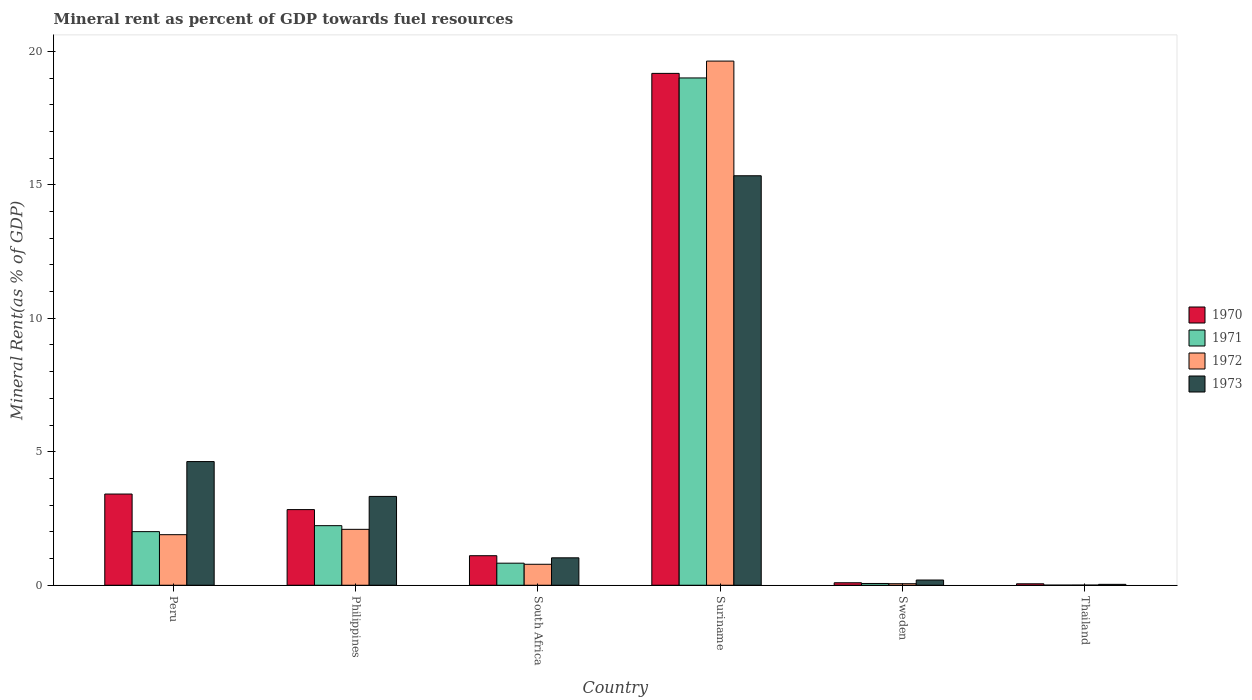How many different coloured bars are there?
Offer a terse response. 4. How many bars are there on the 5th tick from the right?
Provide a succinct answer. 4. In how many cases, is the number of bars for a given country not equal to the number of legend labels?
Ensure brevity in your answer.  0. What is the mineral rent in 1971 in Peru?
Provide a short and direct response. 2.01. Across all countries, what is the maximum mineral rent in 1970?
Offer a terse response. 19.17. Across all countries, what is the minimum mineral rent in 1970?
Make the answer very short. 0.05. In which country was the mineral rent in 1973 maximum?
Provide a short and direct response. Suriname. In which country was the mineral rent in 1972 minimum?
Ensure brevity in your answer.  Thailand. What is the total mineral rent in 1973 in the graph?
Provide a short and direct response. 24.55. What is the difference between the mineral rent in 1972 in Peru and that in South Africa?
Your answer should be very brief. 1.11. What is the difference between the mineral rent in 1971 in Sweden and the mineral rent in 1970 in Peru?
Keep it short and to the point. -3.35. What is the average mineral rent in 1973 per country?
Give a very brief answer. 4.09. What is the difference between the mineral rent of/in 1972 and mineral rent of/in 1971 in Peru?
Make the answer very short. -0.11. What is the ratio of the mineral rent in 1973 in Philippines to that in Suriname?
Give a very brief answer. 0.22. Is the mineral rent in 1973 in Peru less than that in Suriname?
Your answer should be very brief. Yes. Is the difference between the mineral rent in 1972 in South Africa and Sweden greater than the difference between the mineral rent in 1971 in South Africa and Sweden?
Make the answer very short. No. What is the difference between the highest and the second highest mineral rent in 1972?
Give a very brief answer. -0.2. What is the difference between the highest and the lowest mineral rent in 1972?
Your answer should be compact. 19.63. Is it the case that in every country, the sum of the mineral rent in 1971 and mineral rent in 1973 is greater than the sum of mineral rent in 1970 and mineral rent in 1972?
Keep it short and to the point. No. How many bars are there?
Provide a succinct answer. 24. Are all the bars in the graph horizontal?
Your answer should be compact. No. Does the graph contain any zero values?
Your answer should be compact. No. Where does the legend appear in the graph?
Your answer should be very brief. Center right. How many legend labels are there?
Offer a terse response. 4. What is the title of the graph?
Offer a very short reply. Mineral rent as percent of GDP towards fuel resources. Does "1980" appear as one of the legend labels in the graph?
Give a very brief answer. No. What is the label or title of the Y-axis?
Make the answer very short. Mineral Rent(as % of GDP). What is the Mineral Rent(as % of GDP) in 1970 in Peru?
Give a very brief answer. 3.42. What is the Mineral Rent(as % of GDP) in 1971 in Peru?
Provide a succinct answer. 2.01. What is the Mineral Rent(as % of GDP) in 1972 in Peru?
Your answer should be compact. 1.89. What is the Mineral Rent(as % of GDP) in 1973 in Peru?
Keep it short and to the point. 4.63. What is the Mineral Rent(as % of GDP) of 1970 in Philippines?
Ensure brevity in your answer.  2.83. What is the Mineral Rent(as % of GDP) in 1971 in Philippines?
Keep it short and to the point. 2.23. What is the Mineral Rent(as % of GDP) in 1972 in Philippines?
Ensure brevity in your answer.  2.09. What is the Mineral Rent(as % of GDP) in 1973 in Philippines?
Provide a succinct answer. 3.33. What is the Mineral Rent(as % of GDP) in 1970 in South Africa?
Ensure brevity in your answer.  1.11. What is the Mineral Rent(as % of GDP) in 1971 in South Africa?
Offer a terse response. 0.83. What is the Mineral Rent(as % of GDP) of 1972 in South Africa?
Your answer should be very brief. 0.79. What is the Mineral Rent(as % of GDP) in 1973 in South Africa?
Offer a very short reply. 1.03. What is the Mineral Rent(as % of GDP) of 1970 in Suriname?
Keep it short and to the point. 19.17. What is the Mineral Rent(as % of GDP) of 1971 in Suriname?
Your answer should be very brief. 19. What is the Mineral Rent(as % of GDP) in 1972 in Suriname?
Your response must be concise. 19.63. What is the Mineral Rent(as % of GDP) of 1973 in Suriname?
Your answer should be very brief. 15.34. What is the Mineral Rent(as % of GDP) of 1970 in Sweden?
Provide a short and direct response. 0.09. What is the Mineral Rent(as % of GDP) in 1971 in Sweden?
Offer a very short reply. 0.07. What is the Mineral Rent(as % of GDP) of 1972 in Sweden?
Provide a short and direct response. 0.06. What is the Mineral Rent(as % of GDP) in 1973 in Sweden?
Provide a short and direct response. 0.2. What is the Mineral Rent(as % of GDP) in 1970 in Thailand?
Provide a short and direct response. 0.05. What is the Mineral Rent(as % of GDP) in 1971 in Thailand?
Your response must be concise. 0. What is the Mineral Rent(as % of GDP) in 1972 in Thailand?
Give a very brief answer. 0.01. What is the Mineral Rent(as % of GDP) in 1973 in Thailand?
Offer a very short reply. 0.03. Across all countries, what is the maximum Mineral Rent(as % of GDP) in 1970?
Your answer should be very brief. 19.17. Across all countries, what is the maximum Mineral Rent(as % of GDP) in 1971?
Offer a very short reply. 19. Across all countries, what is the maximum Mineral Rent(as % of GDP) in 1972?
Your answer should be compact. 19.63. Across all countries, what is the maximum Mineral Rent(as % of GDP) of 1973?
Your answer should be very brief. 15.34. Across all countries, what is the minimum Mineral Rent(as % of GDP) of 1970?
Give a very brief answer. 0.05. Across all countries, what is the minimum Mineral Rent(as % of GDP) of 1971?
Offer a very short reply. 0. Across all countries, what is the minimum Mineral Rent(as % of GDP) in 1972?
Make the answer very short. 0.01. Across all countries, what is the minimum Mineral Rent(as % of GDP) of 1973?
Give a very brief answer. 0.03. What is the total Mineral Rent(as % of GDP) of 1970 in the graph?
Ensure brevity in your answer.  26.68. What is the total Mineral Rent(as % of GDP) in 1971 in the graph?
Your answer should be compact. 24.14. What is the total Mineral Rent(as % of GDP) in 1972 in the graph?
Your response must be concise. 24.47. What is the total Mineral Rent(as % of GDP) in 1973 in the graph?
Keep it short and to the point. 24.55. What is the difference between the Mineral Rent(as % of GDP) in 1970 in Peru and that in Philippines?
Offer a terse response. 0.58. What is the difference between the Mineral Rent(as % of GDP) of 1971 in Peru and that in Philippines?
Ensure brevity in your answer.  -0.22. What is the difference between the Mineral Rent(as % of GDP) in 1972 in Peru and that in Philippines?
Your answer should be compact. -0.2. What is the difference between the Mineral Rent(as % of GDP) in 1973 in Peru and that in Philippines?
Provide a succinct answer. 1.31. What is the difference between the Mineral Rent(as % of GDP) of 1970 in Peru and that in South Africa?
Your answer should be very brief. 2.31. What is the difference between the Mineral Rent(as % of GDP) in 1971 in Peru and that in South Africa?
Your answer should be very brief. 1.18. What is the difference between the Mineral Rent(as % of GDP) in 1972 in Peru and that in South Africa?
Ensure brevity in your answer.  1.11. What is the difference between the Mineral Rent(as % of GDP) in 1973 in Peru and that in South Africa?
Ensure brevity in your answer.  3.61. What is the difference between the Mineral Rent(as % of GDP) in 1970 in Peru and that in Suriname?
Provide a succinct answer. -15.76. What is the difference between the Mineral Rent(as % of GDP) in 1971 in Peru and that in Suriname?
Your answer should be very brief. -16.99. What is the difference between the Mineral Rent(as % of GDP) in 1972 in Peru and that in Suriname?
Offer a terse response. -17.74. What is the difference between the Mineral Rent(as % of GDP) in 1973 in Peru and that in Suriname?
Offer a very short reply. -10.71. What is the difference between the Mineral Rent(as % of GDP) in 1970 in Peru and that in Sweden?
Your answer should be compact. 3.32. What is the difference between the Mineral Rent(as % of GDP) in 1971 in Peru and that in Sweden?
Ensure brevity in your answer.  1.94. What is the difference between the Mineral Rent(as % of GDP) of 1972 in Peru and that in Sweden?
Provide a succinct answer. 1.84. What is the difference between the Mineral Rent(as % of GDP) of 1973 in Peru and that in Sweden?
Keep it short and to the point. 4.44. What is the difference between the Mineral Rent(as % of GDP) of 1970 in Peru and that in Thailand?
Make the answer very short. 3.36. What is the difference between the Mineral Rent(as % of GDP) of 1971 in Peru and that in Thailand?
Your answer should be very brief. 2. What is the difference between the Mineral Rent(as % of GDP) of 1972 in Peru and that in Thailand?
Your answer should be compact. 1.89. What is the difference between the Mineral Rent(as % of GDP) of 1973 in Peru and that in Thailand?
Provide a short and direct response. 4.6. What is the difference between the Mineral Rent(as % of GDP) of 1970 in Philippines and that in South Africa?
Ensure brevity in your answer.  1.73. What is the difference between the Mineral Rent(as % of GDP) of 1971 in Philippines and that in South Africa?
Provide a succinct answer. 1.41. What is the difference between the Mineral Rent(as % of GDP) of 1972 in Philippines and that in South Africa?
Provide a succinct answer. 1.31. What is the difference between the Mineral Rent(as % of GDP) in 1973 in Philippines and that in South Africa?
Your response must be concise. 2.3. What is the difference between the Mineral Rent(as % of GDP) of 1970 in Philippines and that in Suriname?
Offer a terse response. -16.34. What is the difference between the Mineral Rent(as % of GDP) in 1971 in Philippines and that in Suriname?
Provide a short and direct response. -16.77. What is the difference between the Mineral Rent(as % of GDP) of 1972 in Philippines and that in Suriname?
Provide a short and direct response. -17.54. What is the difference between the Mineral Rent(as % of GDP) in 1973 in Philippines and that in Suriname?
Provide a succinct answer. -12.01. What is the difference between the Mineral Rent(as % of GDP) of 1970 in Philippines and that in Sweden?
Make the answer very short. 2.74. What is the difference between the Mineral Rent(as % of GDP) in 1971 in Philippines and that in Sweden?
Your answer should be very brief. 2.17. What is the difference between the Mineral Rent(as % of GDP) in 1972 in Philippines and that in Sweden?
Your response must be concise. 2.04. What is the difference between the Mineral Rent(as % of GDP) of 1973 in Philippines and that in Sweden?
Give a very brief answer. 3.13. What is the difference between the Mineral Rent(as % of GDP) in 1970 in Philippines and that in Thailand?
Your answer should be very brief. 2.78. What is the difference between the Mineral Rent(as % of GDP) in 1971 in Philippines and that in Thailand?
Your response must be concise. 2.23. What is the difference between the Mineral Rent(as % of GDP) of 1972 in Philippines and that in Thailand?
Provide a succinct answer. 2.09. What is the difference between the Mineral Rent(as % of GDP) in 1973 in Philippines and that in Thailand?
Offer a terse response. 3.29. What is the difference between the Mineral Rent(as % of GDP) in 1970 in South Africa and that in Suriname?
Offer a terse response. -18.07. What is the difference between the Mineral Rent(as % of GDP) of 1971 in South Africa and that in Suriname?
Your answer should be compact. -18.18. What is the difference between the Mineral Rent(as % of GDP) in 1972 in South Africa and that in Suriname?
Keep it short and to the point. -18.85. What is the difference between the Mineral Rent(as % of GDP) in 1973 in South Africa and that in Suriname?
Make the answer very short. -14.31. What is the difference between the Mineral Rent(as % of GDP) of 1970 in South Africa and that in Sweden?
Ensure brevity in your answer.  1.01. What is the difference between the Mineral Rent(as % of GDP) of 1971 in South Africa and that in Sweden?
Provide a succinct answer. 0.76. What is the difference between the Mineral Rent(as % of GDP) of 1972 in South Africa and that in Sweden?
Make the answer very short. 0.73. What is the difference between the Mineral Rent(as % of GDP) of 1973 in South Africa and that in Sweden?
Provide a succinct answer. 0.83. What is the difference between the Mineral Rent(as % of GDP) in 1970 in South Africa and that in Thailand?
Offer a terse response. 1.05. What is the difference between the Mineral Rent(as % of GDP) in 1971 in South Africa and that in Thailand?
Offer a terse response. 0.82. What is the difference between the Mineral Rent(as % of GDP) in 1972 in South Africa and that in Thailand?
Offer a very short reply. 0.78. What is the difference between the Mineral Rent(as % of GDP) in 1973 in South Africa and that in Thailand?
Ensure brevity in your answer.  0.99. What is the difference between the Mineral Rent(as % of GDP) of 1970 in Suriname and that in Sweden?
Keep it short and to the point. 19.08. What is the difference between the Mineral Rent(as % of GDP) in 1971 in Suriname and that in Sweden?
Offer a very short reply. 18.94. What is the difference between the Mineral Rent(as % of GDP) of 1972 in Suriname and that in Sweden?
Keep it short and to the point. 19.58. What is the difference between the Mineral Rent(as % of GDP) of 1973 in Suriname and that in Sweden?
Your response must be concise. 15.14. What is the difference between the Mineral Rent(as % of GDP) in 1970 in Suriname and that in Thailand?
Offer a very short reply. 19.12. What is the difference between the Mineral Rent(as % of GDP) in 1971 in Suriname and that in Thailand?
Your answer should be compact. 19. What is the difference between the Mineral Rent(as % of GDP) in 1972 in Suriname and that in Thailand?
Ensure brevity in your answer.  19.63. What is the difference between the Mineral Rent(as % of GDP) of 1973 in Suriname and that in Thailand?
Your response must be concise. 15.31. What is the difference between the Mineral Rent(as % of GDP) of 1970 in Sweden and that in Thailand?
Offer a terse response. 0.04. What is the difference between the Mineral Rent(as % of GDP) of 1971 in Sweden and that in Thailand?
Your response must be concise. 0.06. What is the difference between the Mineral Rent(as % of GDP) of 1972 in Sweden and that in Thailand?
Offer a very short reply. 0.05. What is the difference between the Mineral Rent(as % of GDP) in 1973 in Sweden and that in Thailand?
Provide a succinct answer. 0.16. What is the difference between the Mineral Rent(as % of GDP) of 1970 in Peru and the Mineral Rent(as % of GDP) of 1971 in Philippines?
Give a very brief answer. 1.18. What is the difference between the Mineral Rent(as % of GDP) in 1970 in Peru and the Mineral Rent(as % of GDP) in 1972 in Philippines?
Offer a very short reply. 1.32. What is the difference between the Mineral Rent(as % of GDP) of 1970 in Peru and the Mineral Rent(as % of GDP) of 1973 in Philippines?
Give a very brief answer. 0.09. What is the difference between the Mineral Rent(as % of GDP) of 1971 in Peru and the Mineral Rent(as % of GDP) of 1972 in Philippines?
Ensure brevity in your answer.  -0.09. What is the difference between the Mineral Rent(as % of GDP) in 1971 in Peru and the Mineral Rent(as % of GDP) in 1973 in Philippines?
Your answer should be compact. -1.32. What is the difference between the Mineral Rent(as % of GDP) in 1972 in Peru and the Mineral Rent(as % of GDP) in 1973 in Philippines?
Your response must be concise. -1.43. What is the difference between the Mineral Rent(as % of GDP) of 1970 in Peru and the Mineral Rent(as % of GDP) of 1971 in South Africa?
Your response must be concise. 2.59. What is the difference between the Mineral Rent(as % of GDP) of 1970 in Peru and the Mineral Rent(as % of GDP) of 1972 in South Africa?
Make the answer very short. 2.63. What is the difference between the Mineral Rent(as % of GDP) in 1970 in Peru and the Mineral Rent(as % of GDP) in 1973 in South Africa?
Provide a succinct answer. 2.39. What is the difference between the Mineral Rent(as % of GDP) of 1971 in Peru and the Mineral Rent(as % of GDP) of 1972 in South Africa?
Offer a terse response. 1.22. What is the difference between the Mineral Rent(as % of GDP) in 1971 in Peru and the Mineral Rent(as % of GDP) in 1973 in South Africa?
Your answer should be compact. 0.98. What is the difference between the Mineral Rent(as % of GDP) in 1972 in Peru and the Mineral Rent(as % of GDP) in 1973 in South Africa?
Ensure brevity in your answer.  0.87. What is the difference between the Mineral Rent(as % of GDP) of 1970 in Peru and the Mineral Rent(as % of GDP) of 1971 in Suriname?
Give a very brief answer. -15.59. What is the difference between the Mineral Rent(as % of GDP) in 1970 in Peru and the Mineral Rent(as % of GDP) in 1972 in Suriname?
Keep it short and to the point. -16.22. What is the difference between the Mineral Rent(as % of GDP) of 1970 in Peru and the Mineral Rent(as % of GDP) of 1973 in Suriname?
Give a very brief answer. -11.92. What is the difference between the Mineral Rent(as % of GDP) of 1971 in Peru and the Mineral Rent(as % of GDP) of 1972 in Suriname?
Your answer should be compact. -17.63. What is the difference between the Mineral Rent(as % of GDP) in 1971 in Peru and the Mineral Rent(as % of GDP) in 1973 in Suriname?
Make the answer very short. -13.33. What is the difference between the Mineral Rent(as % of GDP) of 1972 in Peru and the Mineral Rent(as % of GDP) of 1973 in Suriname?
Keep it short and to the point. -13.44. What is the difference between the Mineral Rent(as % of GDP) in 1970 in Peru and the Mineral Rent(as % of GDP) in 1971 in Sweden?
Your answer should be compact. 3.35. What is the difference between the Mineral Rent(as % of GDP) of 1970 in Peru and the Mineral Rent(as % of GDP) of 1972 in Sweden?
Offer a very short reply. 3.36. What is the difference between the Mineral Rent(as % of GDP) of 1970 in Peru and the Mineral Rent(as % of GDP) of 1973 in Sweden?
Make the answer very short. 3.22. What is the difference between the Mineral Rent(as % of GDP) in 1971 in Peru and the Mineral Rent(as % of GDP) in 1972 in Sweden?
Provide a succinct answer. 1.95. What is the difference between the Mineral Rent(as % of GDP) in 1971 in Peru and the Mineral Rent(as % of GDP) in 1973 in Sweden?
Keep it short and to the point. 1.81. What is the difference between the Mineral Rent(as % of GDP) of 1972 in Peru and the Mineral Rent(as % of GDP) of 1973 in Sweden?
Your answer should be very brief. 1.7. What is the difference between the Mineral Rent(as % of GDP) in 1970 in Peru and the Mineral Rent(as % of GDP) in 1971 in Thailand?
Give a very brief answer. 3.41. What is the difference between the Mineral Rent(as % of GDP) in 1970 in Peru and the Mineral Rent(as % of GDP) in 1972 in Thailand?
Provide a succinct answer. 3.41. What is the difference between the Mineral Rent(as % of GDP) of 1970 in Peru and the Mineral Rent(as % of GDP) of 1973 in Thailand?
Your response must be concise. 3.38. What is the difference between the Mineral Rent(as % of GDP) of 1971 in Peru and the Mineral Rent(as % of GDP) of 1972 in Thailand?
Give a very brief answer. 2. What is the difference between the Mineral Rent(as % of GDP) of 1971 in Peru and the Mineral Rent(as % of GDP) of 1973 in Thailand?
Your answer should be compact. 1.97. What is the difference between the Mineral Rent(as % of GDP) of 1972 in Peru and the Mineral Rent(as % of GDP) of 1973 in Thailand?
Make the answer very short. 1.86. What is the difference between the Mineral Rent(as % of GDP) in 1970 in Philippines and the Mineral Rent(as % of GDP) in 1971 in South Africa?
Give a very brief answer. 2.01. What is the difference between the Mineral Rent(as % of GDP) in 1970 in Philippines and the Mineral Rent(as % of GDP) in 1972 in South Africa?
Your answer should be compact. 2.05. What is the difference between the Mineral Rent(as % of GDP) of 1970 in Philippines and the Mineral Rent(as % of GDP) of 1973 in South Africa?
Your response must be concise. 1.81. What is the difference between the Mineral Rent(as % of GDP) of 1971 in Philippines and the Mineral Rent(as % of GDP) of 1972 in South Africa?
Make the answer very short. 1.45. What is the difference between the Mineral Rent(as % of GDP) in 1971 in Philippines and the Mineral Rent(as % of GDP) in 1973 in South Africa?
Your answer should be very brief. 1.2. What is the difference between the Mineral Rent(as % of GDP) in 1972 in Philippines and the Mineral Rent(as % of GDP) in 1973 in South Africa?
Provide a succinct answer. 1.07. What is the difference between the Mineral Rent(as % of GDP) of 1970 in Philippines and the Mineral Rent(as % of GDP) of 1971 in Suriname?
Your answer should be compact. -16.17. What is the difference between the Mineral Rent(as % of GDP) of 1970 in Philippines and the Mineral Rent(as % of GDP) of 1972 in Suriname?
Make the answer very short. -16.8. What is the difference between the Mineral Rent(as % of GDP) in 1970 in Philippines and the Mineral Rent(as % of GDP) in 1973 in Suriname?
Offer a terse response. -12.51. What is the difference between the Mineral Rent(as % of GDP) in 1971 in Philippines and the Mineral Rent(as % of GDP) in 1972 in Suriname?
Your answer should be compact. -17.4. What is the difference between the Mineral Rent(as % of GDP) in 1971 in Philippines and the Mineral Rent(as % of GDP) in 1973 in Suriname?
Your response must be concise. -13.11. What is the difference between the Mineral Rent(as % of GDP) of 1972 in Philippines and the Mineral Rent(as % of GDP) of 1973 in Suriname?
Your response must be concise. -13.24. What is the difference between the Mineral Rent(as % of GDP) in 1970 in Philippines and the Mineral Rent(as % of GDP) in 1971 in Sweden?
Offer a terse response. 2.77. What is the difference between the Mineral Rent(as % of GDP) in 1970 in Philippines and the Mineral Rent(as % of GDP) in 1972 in Sweden?
Give a very brief answer. 2.78. What is the difference between the Mineral Rent(as % of GDP) of 1970 in Philippines and the Mineral Rent(as % of GDP) of 1973 in Sweden?
Make the answer very short. 2.64. What is the difference between the Mineral Rent(as % of GDP) of 1971 in Philippines and the Mineral Rent(as % of GDP) of 1972 in Sweden?
Provide a short and direct response. 2.17. What is the difference between the Mineral Rent(as % of GDP) of 1971 in Philippines and the Mineral Rent(as % of GDP) of 1973 in Sweden?
Your response must be concise. 2.04. What is the difference between the Mineral Rent(as % of GDP) in 1972 in Philippines and the Mineral Rent(as % of GDP) in 1973 in Sweden?
Offer a terse response. 1.9. What is the difference between the Mineral Rent(as % of GDP) of 1970 in Philippines and the Mineral Rent(as % of GDP) of 1971 in Thailand?
Your answer should be compact. 2.83. What is the difference between the Mineral Rent(as % of GDP) in 1970 in Philippines and the Mineral Rent(as % of GDP) in 1972 in Thailand?
Your response must be concise. 2.83. What is the difference between the Mineral Rent(as % of GDP) in 1970 in Philippines and the Mineral Rent(as % of GDP) in 1973 in Thailand?
Offer a very short reply. 2.8. What is the difference between the Mineral Rent(as % of GDP) of 1971 in Philippines and the Mineral Rent(as % of GDP) of 1972 in Thailand?
Give a very brief answer. 2.23. What is the difference between the Mineral Rent(as % of GDP) of 1971 in Philippines and the Mineral Rent(as % of GDP) of 1973 in Thailand?
Give a very brief answer. 2.2. What is the difference between the Mineral Rent(as % of GDP) of 1972 in Philippines and the Mineral Rent(as % of GDP) of 1973 in Thailand?
Provide a short and direct response. 2.06. What is the difference between the Mineral Rent(as % of GDP) in 1970 in South Africa and the Mineral Rent(as % of GDP) in 1971 in Suriname?
Ensure brevity in your answer.  -17.9. What is the difference between the Mineral Rent(as % of GDP) in 1970 in South Africa and the Mineral Rent(as % of GDP) in 1972 in Suriname?
Offer a very short reply. -18.53. What is the difference between the Mineral Rent(as % of GDP) of 1970 in South Africa and the Mineral Rent(as % of GDP) of 1973 in Suriname?
Your answer should be very brief. -14.23. What is the difference between the Mineral Rent(as % of GDP) in 1971 in South Africa and the Mineral Rent(as % of GDP) in 1972 in Suriname?
Offer a terse response. -18.81. What is the difference between the Mineral Rent(as % of GDP) in 1971 in South Africa and the Mineral Rent(as % of GDP) in 1973 in Suriname?
Give a very brief answer. -14.51. What is the difference between the Mineral Rent(as % of GDP) of 1972 in South Africa and the Mineral Rent(as % of GDP) of 1973 in Suriname?
Offer a terse response. -14.55. What is the difference between the Mineral Rent(as % of GDP) in 1970 in South Africa and the Mineral Rent(as % of GDP) in 1971 in Sweden?
Offer a very short reply. 1.04. What is the difference between the Mineral Rent(as % of GDP) of 1970 in South Africa and the Mineral Rent(as % of GDP) of 1972 in Sweden?
Your response must be concise. 1.05. What is the difference between the Mineral Rent(as % of GDP) of 1970 in South Africa and the Mineral Rent(as % of GDP) of 1973 in Sweden?
Offer a terse response. 0.91. What is the difference between the Mineral Rent(as % of GDP) of 1971 in South Africa and the Mineral Rent(as % of GDP) of 1972 in Sweden?
Your answer should be very brief. 0.77. What is the difference between the Mineral Rent(as % of GDP) of 1971 in South Africa and the Mineral Rent(as % of GDP) of 1973 in Sweden?
Provide a short and direct response. 0.63. What is the difference between the Mineral Rent(as % of GDP) in 1972 in South Africa and the Mineral Rent(as % of GDP) in 1973 in Sweden?
Make the answer very short. 0.59. What is the difference between the Mineral Rent(as % of GDP) in 1970 in South Africa and the Mineral Rent(as % of GDP) in 1971 in Thailand?
Make the answer very short. 1.1. What is the difference between the Mineral Rent(as % of GDP) in 1970 in South Africa and the Mineral Rent(as % of GDP) in 1972 in Thailand?
Give a very brief answer. 1.1. What is the difference between the Mineral Rent(as % of GDP) of 1970 in South Africa and the Mineral Rent(as % of GDP) of 1973 in Thailand?
Your answer should be compact. 1.07. What is the difference between the Mineral Rent(as % of GDP) in 1971 in South Africa and the Mineral Rent(as % of GDP) in 1972 in Thailand?
Provide a short and direct response. 0.82. What is the difference between the Mineral Rent(as % of GDP) of 1971 in South Africa and the Mineral Rent(as % of GDP) of 1973 in Thailand?
Keep it short and to the point. 0.79. What is the difference between the Mineral Rent(as % of GDP) of 1972 in South Africa and the Mineral Rent(as % of GDP) of 1973 in Thailand?
Give a very brief answer. 0.75. What is the difference between the Mineral Rent(as % of GDP) in 1970 in Suriname and the Mineral Rent(as % of GDP) in 1971 in Sweden?
Your answer should be very brief. 19.11. What is the difference between the Mineral Rent(as % of GDP) of 1970 in Suriname and the Mineral Rent(as % of GDP) of 1972 in Sweden?
Give a very brief answer. 19.12. What is the difference between the Mineral Rent(as % of GDP) of 1970 in Suriname and the Mineral Rent(as % of GDP) of 1973 in Sweden?
Your response must be concise. 18.98. What is the difference between the Mineral Rent(as % of GDP) of 1971 in Suriname and the Mineral Rent(as % of GDP) of 1972 in Sweden?
Your answer should be very brief. 18.95. What is the difference between the Mineral Rent(as % of GDP) in 1971 in Suriname and the Mineral Rent(as % of GDP) in 1973 in Sweden?
Offer a terse response. 18.81. What is the difference between the Mineral Rent(as % of GDP) of 1972 in Suriname and the Mineral Rent(as % of GDP) of 1973 in Sweden?
Keep it short and to the point. 19.44. What is the difference between the Mineral Rent(as % of GDP) in 1970 in Suriname and the Mineral Rent(as % of GDP) in 1971 in Thailand?
Provide a succinct answer. 19.17. What is the difference between the Mineral Rent(as % of GDP) in 1970 in Suriname and the Mineral Rent(as % of GDP) in 1972 in Thailand?
Provide a succinct answer. 19.17. What is the difference between the Mineral Rent(as % of GDP) of 1970 in Suriname and the Mineral Rent(as % of GDP) of 1973 in Thailand?
Your response must be concise. 19.14. What is the difference between the Mineral Rent(as % of GDP) of 1971 in Suriname and the Mineral Rent(as % of GDP) of 1972 in Thailand?
Offer a terse response. 19. What is the difference between the Mineral Rent(as % of GDP) of 1971 in Suriname and the Mineral Rent(as % of GDP) of 1973 in Thailand?
Ensure brevity in your answer.  18.97. What is the difference between the Mineral Rent(as % of GDP) of 1972 in Suriname and the Mineral Rent(as % of GDP) of 1973 in Thailand?
Ensure brevity in your answer.  19.6. What is the difference between the Mineral Rent(as % of GDP) of 1970 in Sweden and the Mineral Rent(as % of GDP) of 1971 in Thailand?
Offer a terse response. 0.09. What is the difference between the Mineral Rent(as % of GDP) in 1970 in Sweden and the Mineral Rent(as % of GDP) in 1972 in Thailand?
Give a very brief answer. 0.09. What is the difference between the Mineral Rent(as % of GDP) in 1970 in Sweden and the Mineral Rent(as % of GDP) in 1973 in Thailand?
Make the answer very short. 0.06. What is the difference between the Mineral Rent(as % of GDP) of 1971 in Sweden and the Mineral Rent(as % of GDP) of 1972 in Thailand?
Your response must be concise. 0.06. What is the difference between the Mineral Rent(as % of GDP) in 1971 in Sweden and the Mineral Rent(as % of GDP) in 1973 in Thailand?
Your answer should be compact. 0.03. What is the difference between the Mineral Rent(as % of GDP) of 1972 in Sweden and the Mineral Rent(as % of GDP) of 1973 in Thailand?
Your response must be concise. 0.02. What is the average Mineral Rent(as % of GDP) in 1970 per country?
Your response must be concise. 4.45. What is the average Mineral Rent(as % of GDP) of 1971 per country?
Your response must be concise. 4.02. What is the average Mineral Rent(as % of GDP) of 1972 per country?
Offer a very short reply. 4.08. What is the average Mineral Rent(as % of GDP) in 1973 per country?
Your answer should be compact. 4.09. What is the difference between the Mineral Rent(as % of GDP) of 1970 and Mineral Rent(as % of GDP) of 1971 in Peru?
Offer a terse response. 1.41. What is the difference between the Mineral Rent(as % of GDP) of 1970 and Mineral Rent(as % of GDP) of 1972 in Peru?
Offer a terse response. 1.52. What is the difference between the Mineral Rent(as % of GDP) in 1970 and Mineral Rent(as % of GDP) in 1973 in Peru?
Provide a short and direct response. -1.22. What is the difference between the Mineral Rent(as % of GDP) of 1971 and Mineral Rent(as % of GDP) of 1972 in Peru?
Keep it short and to the point. 0.11. What is the difference between the Mineral Rent(as % of GDP) of 1971 and Mineral Rent(as % of GDP) of 1973 in Peru?
Give a very brief answer. -2.62. What is the difference between the Mineral Rent(as % of GDP) in 1972 and Mineral Rent(as % of GDP) in 1973 in Peru?
Offer a terse response. -2.74. What is the difference between the Mineral Rent(as % of GDP) of 1970 and Mineral Rent(as % of GDP) of 1971 in Philippines?
Offer a very short reply. 0.6. What is the difference between the Mineral Rent(as % of GDP) in 1970 and Mineral Rent(as % of GDP) in 1972 in Philippines?
Your answer should be compact. 0.74. What is the difference between the Mineral Rent(as % of GDP) in 1970 and Mineral Rent(as % of GDP) in 1973 in Philippines?
Offer a very short reply. -0.49. What is the difference between the Mineral Rent(as % of GDP) in 1971 and Mineral Rent(as % of GDP) in 1972 in Philippines?
Provide a short and direct response. 0.14. What is the difference between the Mineral Rent(as % of GDP) of 1971 and Mineral Rent(as % of GDP) of 1973 in Philippines?
Your answer should be compact. -1.1. What is the difference between the Mineral Rent(as % of GDP) of 1972 and Mineral Rent(as % of GDP) of 1973 in Philippines?
Ensure brevity in your answer.  -1.23. What is the difference between the Mineral Rent(as % of GDP) of 1970 and Mineral Rent(as % of GDP) of 1971 in South Africa?
Your answer should be compact. 0.28. What is the difference between the Mineral Rent(as % of GDP) in 1970 and Mineral Rent(as % of GDP) in 1972 in South Africa?
Your answer should be compact. 0.32. What is the difference between the Mineral Rent(as % of GDP) of 1970 and Mineral Rent(as % of GDP) of 1973 in South Africa?
Offer a very short reply. 0.08. What is the difference between the Mineral Rent(as % of GDP) of 1971 and Mineral Rent(as % of GDP) of 1972 in South Africa?
Your answer should be compact. 0.04. What is the difference between the Mineral Rent(as % of GDP) in 1971 and Mineral Rent(as % of GDP) in 1973 in South Africa?
Your answer should be compact. -0.2. What is the difference between the Mineral Rent(as % of GDP) of 1972 and Mineral Rent(as % of GDP) of 1973 in South Africa?
Offer a terse response. -0.24. What is the difference between the Mineral Rent(as % of GDP) in 1970 and Mineral Rent(as % of GDP) in 1971 in Suriname?
Provide a short and direct response. 0.17. What is the difference between the Mineral Rent(as % of GDP) in 1970 and Mineral Rent(as % of GDP) in 1972 in Suriname?
Give a very brief answer. -0.46. What is the difference between the Mineral Rent(as % of GDP) in 1970 and Mineral Rent(as % of GDP) in 1973 in Suriname?
Your answer should be very brief. 3.84. What is the difference between the Mineral Rent(as % of GDP) of 1971 and Mineral Rent(as % of GDP) of 1972 in Suriname?
Provide a succinct answer. -0.63. What is the difference between the Mineral Rent(as % of GDP) of 1971 and Mineral Rent(as % of GDP) of 1973 in Suriname?
Your answer should be compact. 3.66. What is the difference between the Mineral Rent(as % of GDP) of 1972 and Mineral Rent(as % of GDP) of 1973 in Suriname?
Keep it short and to the point. 4.3. What is the difference between the Mineral Rent(as % of GDP) of 1970 and Mineral Rent(as % of GDP) of 1971 in Sweden?
Keep it short and to the point. 0.03. What is the difference between the Mineral Rent(as % of GDP) of 1970 and Mineral Rent(as % of GDP) of 1972 in Sweden?
Give a very brief answer. 0.04. What is the difference between the Mineral Rent(as % of GDP) of 1970 and Mineral Rent(as % of GDP) of 1973 in Sweden?
Your answer should be very brief. -0.1. What is the difference between the Mineral Rent(as % of GDP) of 1971 and Mineral Rent(as % of GDP) of 1972 in Sweden?
Ensure brevity in your answer.  0.01. What is the difference between the Mineral Rent(as % of GDP) in 1971 and Mineral Rent(as % of GDP) in 1973 in Sweden?
Give a very brief answer. -0.13. What is the difference between the Mineral Rent(as % of GDP) of 1972 and Mineral Rent(as % of GDP) of 1973 in Sweden?
Provide a short and direct response. -0.14. What is the difference between the Mineral Rent(as % of GDP) of 1970 and Mineral Rent(as % of GDP) of 1971 in Thailand?
Offer a terse response. 0.05. What is the difference between the Mineral Rent(as % of GDP) in 1970 and Mineral Rent(as % of GDP) in 1972 in Thailand?
Offer a very short reply. 0.05. What is the difference between the Mineral Rent(as % of GDP) of 1970 and Mineral Rent(as % of GDP) of 1973 in Thailand?
Keep it short and to the point. 0.02. What is the difference between the Mineral Rent(as % of GDP) of 1971 and Mineral Rent(as % of GDP) of 1972 in Thailand?
Provide a succinct answer. -0. What is the difference between the Mineral Rent(as % of GDP) in 1971 and Mineral Rent(as % of GDP) in 1973 in Thailand?
Offer a terse response. -0.03. What is the difference between the Mineral Rent(as % of GDP) of 1972 and Mineral Rent(as % of GDP) of 1973 in Thailand?
Your answer should be compact. -0.03. What is the ratio of the Mineral Rent(as % of GDP) of 1970 in Peru to that in Philippines?
Offer a terse response. 1.21. What is the ratio of the Mineral Rent(as % of GDP) in 1971 in Peru to that in Philippines?
Ensure brevity in your answer.  0.9. What is the ratio of the Mineral Rent(as % of GDP) of 1972 in Peru to that in Philippines?
Provide a short and direct response. 0.9. What is the ratio of the Mineral Rent(as % of GDP) of 1973 in Peru to that in Philippines?
Your answer should be very brief. 1.39. What is the ratio of the Mineral Rent(as % of GDP) of 1970 in Peru to that in South Africa?
Make the answer very short. 3.09. What is the ratio of the Mineral Rent(as % of GDP) in 1971 in Peru to that in South Africa?
Make the answer very short. 2.43. What is the ratio of the Mineral Rent(as % of GDP) of 1972 in Peru to that in South Africa?
Offer a very short reply. 2.41. What is the ratio of the Mineral Rent(as % of GDP) in 1973 in Peru to that in South Africa?
Your response must be concise. 4.51. What is the ratio of the Mineral Rent(as % of GDP) in 1970 in Peru to that in Suriname?
Give a very brief answer. 0.18. What is the ratio of the Mineral Rent(as % of GDP) of 1971 in Peru to that in Suriname?
Provide a short and direct response. 0.11. What is the ratio of the Mineral Rent(as % of GDP) of 1972 in Peru to that in Suriname?
Make the answer very short. 0.1. What is the ratio of the Mineral Rent(as % of GDP) of 1973 in Peru to that in Suriname?
Provide a short and direct response. 0.3. What is the ratio of the Mineral Rent(as % of GDP) of 1970 in Peru to that in Sweden?
Your answer should be very brief. 36.88. What is the ratio of the Mineral Rent(as % of GDP) of 1971 in Peru to that in Sweden?
Your answer should be compact. 30.33. What is the ratio of the Mineral Rent(as % of GDP) of 1972 in Peru to that in Sweden?
Your answer should be compact. 32.98. What is the ratio of the Mineral Rent(as % of GDP) of 1973 in Peru to that in Sweden?
Your answer should be very brief. 23.72. What is the ratio of the Mineral Rent(as % of GDP) of 1970 in Peru to that in Thailand?
Keep it short and to the point. 63.26. What is the ratio of the Mineral Rent(as % of GDP) of 1971 in Peru to that in Thailand?
Give a very brief answer. 627.74. What is the ratio of the Mineral Rent(as % of GDP) of 1972 in Peru to that in Thailand?
Your answer should be compact. 373.59. What is the ratio of the Mineral Rent(as % of GDP) of 1973 in Peru to that in Thailand?
Provide a short and direct response. 139.88. What is the ratio of the Mineral Rent(as % of GDP) in 1970 in Philippines to that in South Africa?
Make the answer very short. 2.56. What is the ratio of the Mineral Rent(as % of GDP) in 1971 in Philippines to that in South Africa?
Ensure brevity in your answer.  2.7. What is the ratio of the Mineral Rent(as % of GDP) of 1972 in Philippines to that in South Africa?
Provide a succinct answer. 2.67. What is the ratio of the Mineral Rent(as % of GDP) of 1973 in Philippines to that in South Africa?
Provide a short and direct response. 3.24. What is the ratio of the Mineral Rent(as % of GDP) of 1970 in Philippines to that in Suriname?
Give a very brief answer. 0.15. What is the ratio of the Mineral Rent(as % of GDP) in 1971 in Philippines to that in Suriname?
Your answer should be very brief. 0.12. What is the ratio of the Mineral Rent(as % of GDP) of 1972 in Philippines to that in Suriname?
Ensure brevity in your answer.  0.11. What is the ratio of the Mineral Rent(as % of GDP) in 1973 in Philippines to that in Suriname?
Provide a short and direct response. 0.22. What is the ratio of the Mineral Rent(as % of GDP) in 1970 in Philippines to that in Sweden?
Your answer should be compact. 30.59. What is the ratio of the Mineral Rent(as % of GDP) in 1971 in Philippines to that in Sweden?
Offer a very short reply. 33.7. What is the ratio of the Mineral Rent(as % of GDP) of 1972 in Philippines to that in Sweden?
Offer a very short reply. 36.47. What is the ratio of the Mineral Rent(as % of GDP) of 1973 in Philippines to that in Sweden?
Make the answer very short. 17.03. What is the ratio of the Mineral Rent(as % of GDP) of 1970 in Philippines to that in Thailand?
Your answer should be very brief. 52.47. What is the ratio of the Mineral Rent(as % of GDP) in 1971 in Philippines to that in Thailand?
Make the answer very short. 697.65. What is the ratio of the Mineral Rent(as % of GDP) in 1972 in Philippines to that in Thailand?
Make the answer very short. 413.11. What is the ratio of the Mineral Rent(as % of GDP) in 1973 in Philippines to that in Thailand?
Make the answer very short. 100.47. What is the ratio of the Mineral Rent(as % of GDP) in 1970 in South Africa to that in Suriname?
Keep it short and to the point. 0.06. What is the ratio of the Mineral Rent(as % of GDP) of 1971 in South Africa to that in Suriname?
Ensure brevity in your answer.  0.04. What is the ratio of the Mineral Rent(as % of GDP) of 1972 in South Africa to that in Suriname?
Give a very brief answer. 0.04. What is the ratio of the Mineral Rent(as % of GDP) of 1973 in South Africa to that in Suriname?
Keep it short and to the point. 0.07. What is the ratio of the Mineral Rent(as % of GDP) of 1970 in South Africa to that in Sweden?
Make the answer very short. 11.94. What is the ratio of the Mineral Rent(as % of GDP) of 1971 in South Africa to that in Sweden?
Your answer should be compact. 12.48. What is the ratio of the Mineral Rent(as % of GDP) in 1972 in South Africa to that in Sweden?
Provide a succinct answer. 13.67. What is the ratio of the Mineral Rent(as % of GDP) of 1973 in South Africa to that in Sweden?
Make the answer very short. 5.26. What is the ratio of the Mineral Rent(as % of GDP) of 1970 in South Africa to that in Thailand?
Give a very brief answer. 20.48. What is the ratio of the Mineral Rent(as % of GDP) of 1971 in South Africa to that in Thailand?
Provide a short and direct response. 258.3. What is the ratio of the Mineral Rent(as % of GDP) in 1972 in South Africa to that in Thailand?
Your answer should be very brief. 154.88. What is the ratio of the Mineral Rent(as % of GDP) of 1973 in South Africa to that in Thailand?
Your answer should be very brief. 31.01. What is the ratio of the Mineral Rent(as % of GDP) of 1970 in Suriname to that in Sweden?
Ensure brevity in your answer.  207. What is the ratio of the Mineral Rent(as % of GDP) of 1971 in Suriname to that in Sweden?
Your answer should be very brief. 287. What is the ratio of the Mineral Rent(as % of GDP) in 1972 in Suriname to that in Sweden?
Keep it short and to the point. 341.94. What is the ratio of the Mineral Rent(as % of GDP) of 1973 in Suriname to that in Sweden?
Your response must be concise. 78.52. What is the ratio of the Mineral Rent(as % of GDP) in 1970 in Suriname to that in Thailand?
Offer a terse response. 355.06. What is the ratio of the Mineral Rent(as % of GDP) of 1971 in Suriname to that in Thailand?
Your answer should be very brief. 5940.64. What is the ratio of the Mineral Rent(as % of GDP) in 1972 in Suriname to that in Thailand?
Your answer should be compact. 3873.35. What is the ratio of the Mineral Rent(as % of GDP) in 1973 in Suriname to that in Thailand?
Keep it short and to the point. 463.15. What is the ratio of the Mineral Rent(as % of GDP) of 1970 in Sweden to that in Thailand?
Provide a short and direct response. 1.72. What is the ratio of the Mineral Rent(as % of GDP) of 1971 in Sweden to that in Thailand?
Provide a short and direct response. 20.7. What is the ratio of the Mineral Rent(as % of GDP) of 1972 in Sweden to that in Thailand?
Give a very brief answer. 11.33. What is the ratio of the Mineral Rent(as % of GDP) in 1973 in Sweden to that in Thailand?
Give a very brief answer. 5.9. What is the difference between the highest and the second highest Mineral Rent(as % of GDP) in 1970?
Your answer should be very brief. 15.76. What is the difference between the highest and the second highest Mineral Rent(as % of GDP) of 1971?
Offer a very short reply. 16.77. What is the difference between the highest and the second highest Mineral Rent(as % of GDP) in 1972?
Offer a very short reply. 17.54. What is the difference between the highest and the second highest Mineral Rent(as % of GDP) of 1973?
Your answer should be very brief. 10.71. What is the difference between the highest and the lowest Mineral Rent(as % of GDP) in 1970?
Your response must be concise. 19.12. What is the difference between the highest and the lowest Mineral Rent(as % of GDP) of 1971?
Your response must be concise. 19. What is the difference between the highest and the lowest Mineral Rent(as % of GDP) of 1972?
Give a very brief answer. 19.63. What is the difference between the highest and the lowest Mineral Rent(as % of GDP) of 1973?
Ensure brevity in your answer.  15.31. 